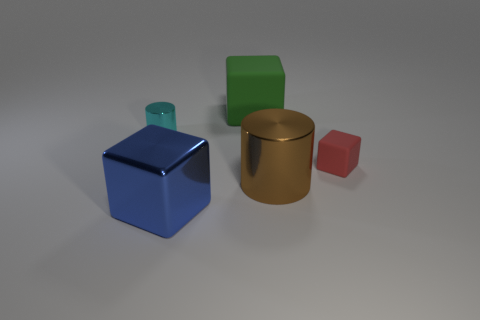What number of large things are green balls or green things?
Ensure brevity in your answer.  1. The large object that is both to the left of the big brown cylinder and behind the metal cube has what shape?
Your response must be concise. Cube. Do the cyan thing and the green block have the same material?
Your answer should be compact. No. The rubber object that is the same size as the shiny cube is what color?
Your answer should be very brief. Green. There is a big thing that is both behind the blue thing and in front of the small cyan cylinder; what is its color?
Provide a short and direct response. Brown. How big is the cylinder that is to the left of the cube that is left of the thing that is behind the tiny metal cylinder?
Give a very brief answer. Small. What is the blue block made of?
Give a very brief answer. Metal. Are the big brown object and the cylinder behind the tiny red rubber thing made of the same material?
Keep it short and to the point. Yes. Is there anything else that is the same color as the tiny rubber cube?
Offer a terse response. No. Is there a large shiny thing left of the shiny thing behind the cube to the right of the brown thing?
Offer a terse response. No. 